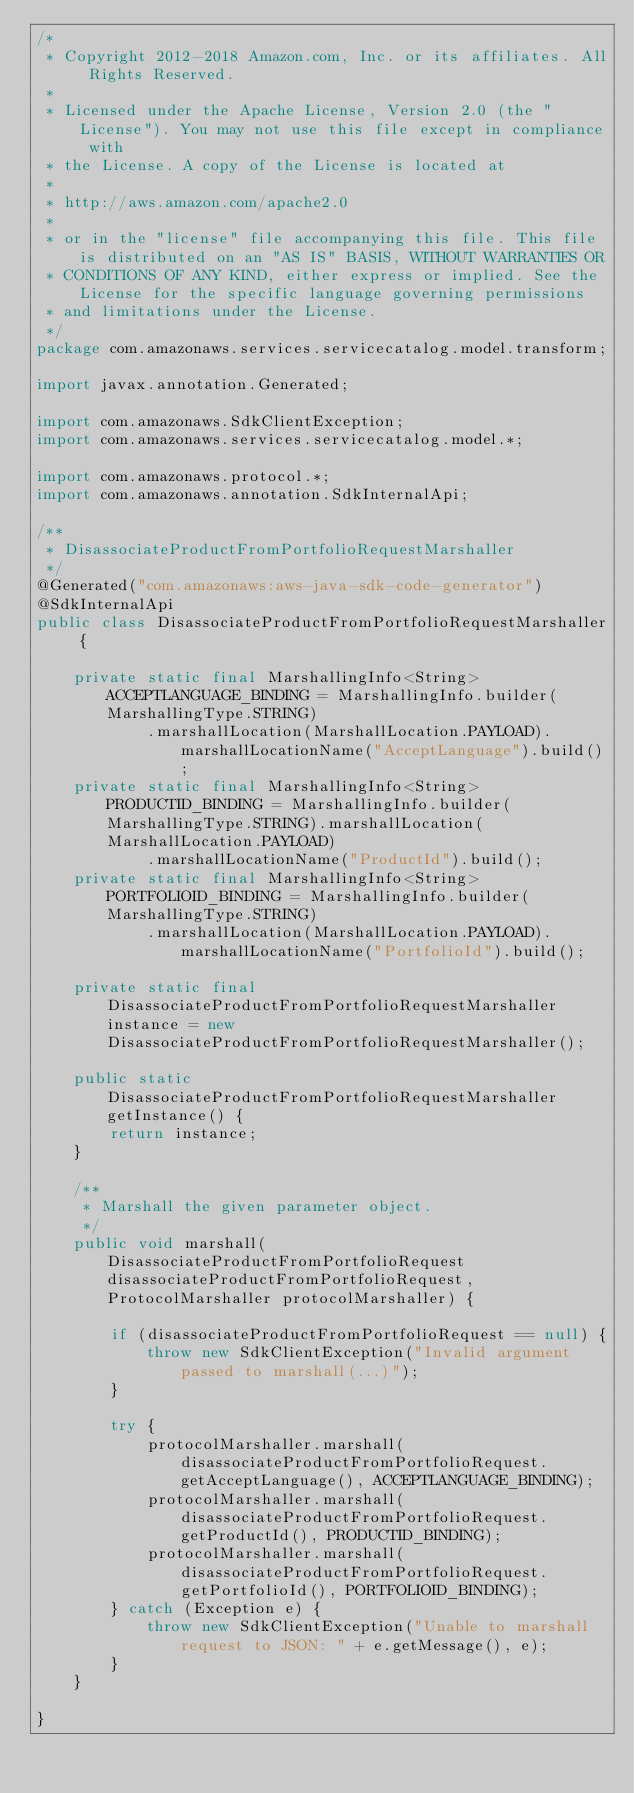<code> <loc_0><loc_0><loc_500><loc_500><_Java_>/*
 * Copyright 2012-2018 Amazon.com, Inc. or its affiliates. All Rights Reserved.
 * 
 * Licensed under the Apache License, Version 2.0 (the "License"). You may not use this file except in compliance with
 * the License. A copy of the License is located at
 * 
 * http://aws.amazon.com/apache2.0
 * 
 * or in the "license" file accompanying this file. This file is distributed on an "AS IS" BASIS, WITHOUT WARRANTIES OR
 * CONDITIONS OF ANY KIND, either express or implied. See the License for the specific language governing permissions
 * and limitations under the License.
 */
package com.amazonaws.services.servicecatalog.model.transform;

import javax.annotation.Generated;

import com.amazonaws.SdkClientException;
import com.amazonaws.services.servicecatalog.model.*;

import com.amazonaws.protocol.*;
import com.amazonaws.annotation.SdkInternalApi;

/**
 * DisassociateProductFromPortfolioRequestMarshaller
 */
@Generated("com.amazonaws:aws-java-sdk-code-generator")
@SdkInternalApi
public class DisassociateProductFromPortfolioRequestMarshaller {

    private static final MarshallingInfo<String> ACCEPTLANGUAGE_BINDING = MarshallingInfo.builder(MarshallingType.STRING)
            .marshallLocation(MarshallLocation.PAYLOAD).marshallLocationName("AcceptLanguage").build();
    private static final MarshallingInfo<String> PRODUCTID_BINDING = MarshallingInfo.builder(MarshallingType.STRING).marshallLocation(MarshallLocation.PAYLOAD)
            .marshallLocationName("ProductId").build();
    private static final MarshallingInfo<String> PORTFOLIOID_BINDING = MarshallingInfo.builder(MarshallingType.STRING)
            .marshallLocation(MarshallLocation.PAYLOAD).marshallLocationName("PortfolioId").build();

    private static final DisassociateProductFromPortfolioRequestMarshaller instance = new DisassociateProductFromPortfolioRequestMarshaller();

    public static DisassociateProductFromPortfolioRequestMarshaller getInstance() {
        return instance;
    }

    /**
     * Marshall the given parameter object.
     */
    public void marshall(DisassociateProductFromPortfolioRequest disassociateProductFromPortfolioRequest, ProtocolMarshaller protocolMarshaller) {

        if (disassociateProductFromPortfolioRequest == null) {
            throw new SdkClientException("Invalid argument passed to marshall(...)");
        }

        try {
            protocolMarshaller.marshall(disassociateProductFromPortfolioRequest.getAcceptLanguage(), ACCEPTLANGUAGE_BINDING);
            protocolMarshaller.marshall(disassociateProductFromPortfolioRequest.getProductId(), PRODUCTID_BINDING);
            protocolMarshaller.marshall(disassociateProductFromPortfolioRequest.getPortfolioId(), PORTFOLIOID_BINDING);
        } catch (Exception e) {
            throw new SdkClientException("Unable to marshall request to JSON: " + e.getMessage(), e);
        }
    }

}
</code> 